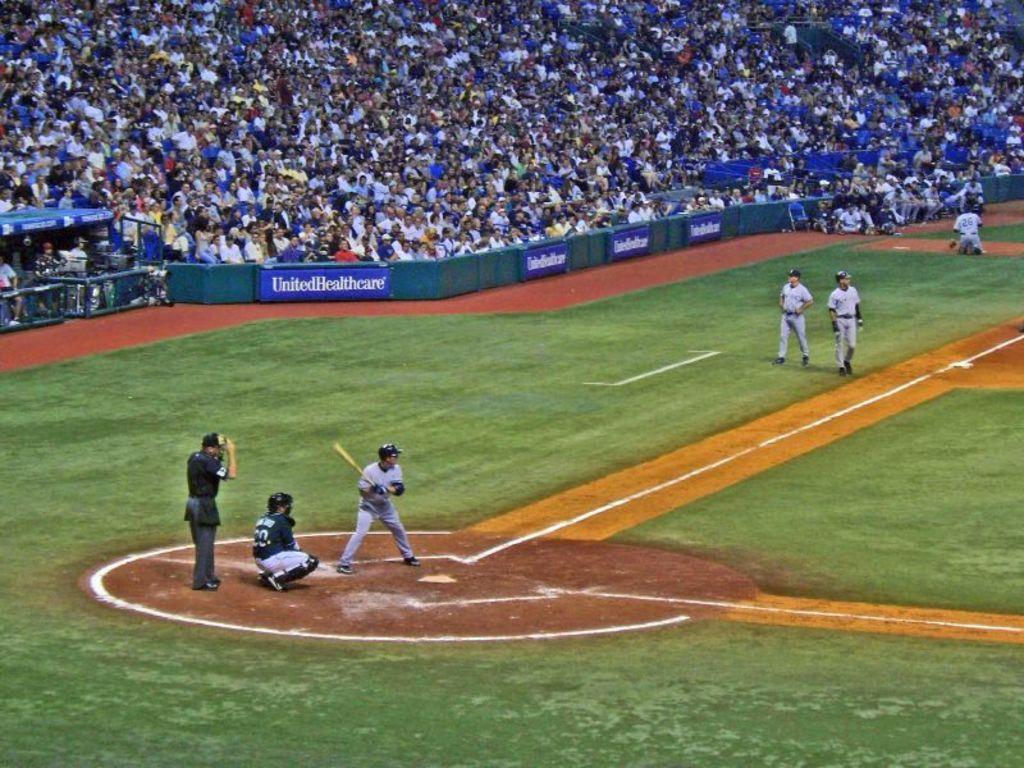Could you give a brief overview of what you see in this image? In this image there are three players are at bottom left side of this image and there are some players at right side of this image and there is a ground at bottom of this image and there are some audience at top of this image and there is a fencing wall in middle of this image. 